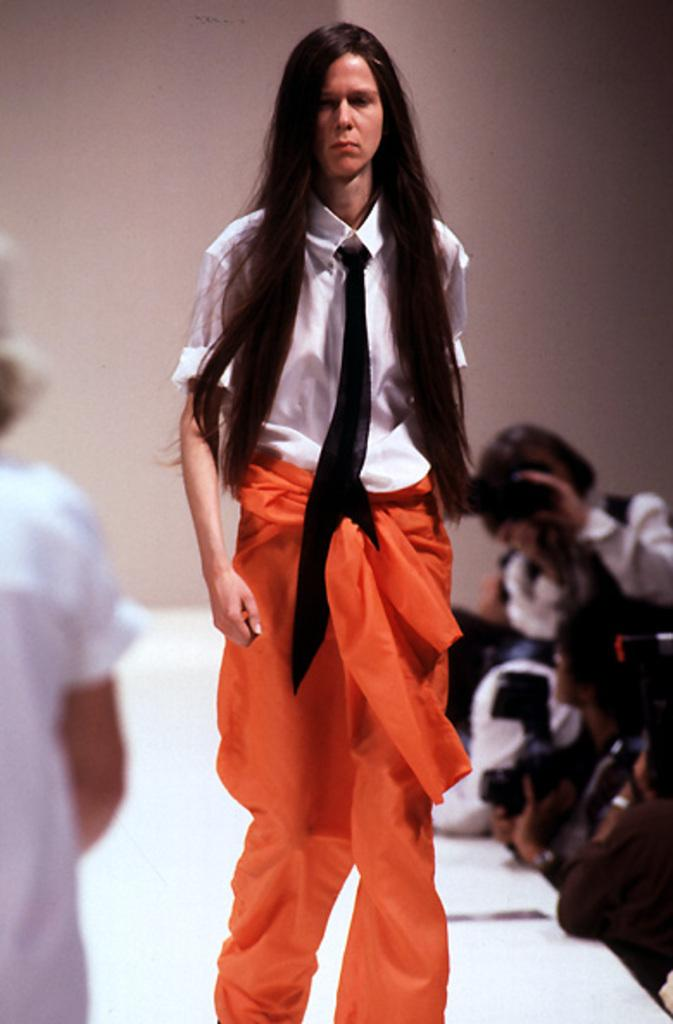What is: What is happening in the front of the image? There is a person walking in the front of the image. What can be seen in the background of the image? There are persons in the background of the image. What are some of the persons in the image doing? There are persons holding cameras in their hands on the right side of the image. What is a prominent feature in the image? There is a wall in the image. Can you see any sailboats on the lake in the image? There is no lake or sailboats present in the image. What type of system is being used by the persons in the image? The provided facts do not mention any specific system being used by the persons in the image. 